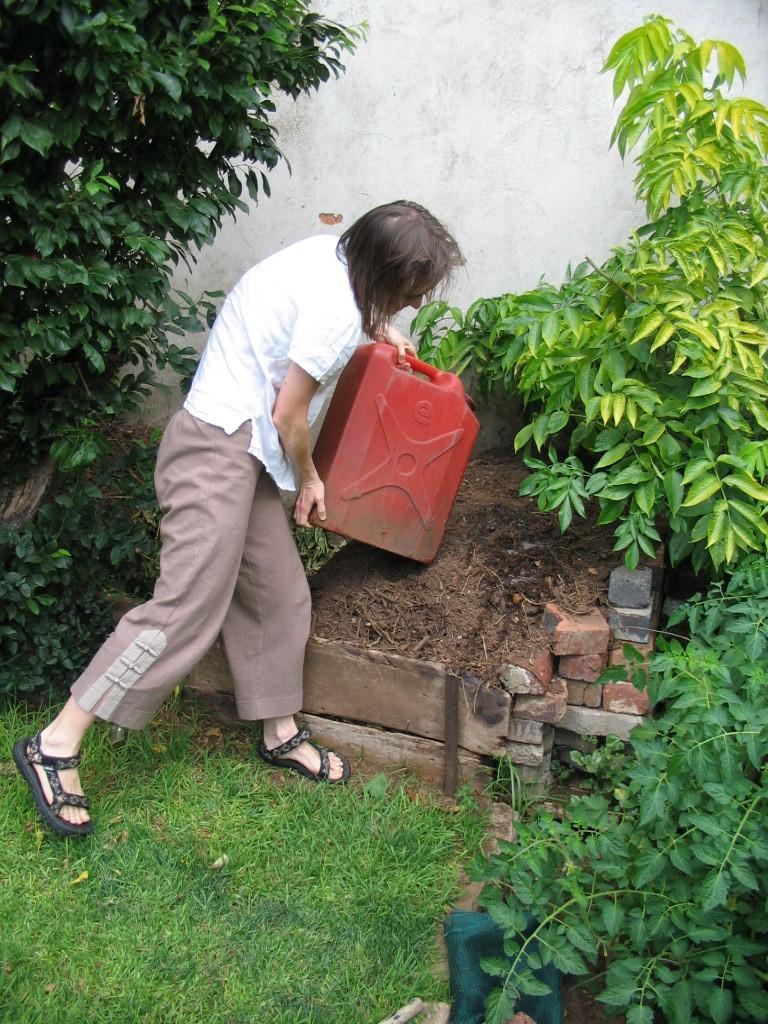Can you describe this image briefly? In this picture I can see there is a man standing wearing a white shirt and a pant and holding a red color object and there is soil where, grass on the floor and plants and trees and there is a wall in the backdrop. 